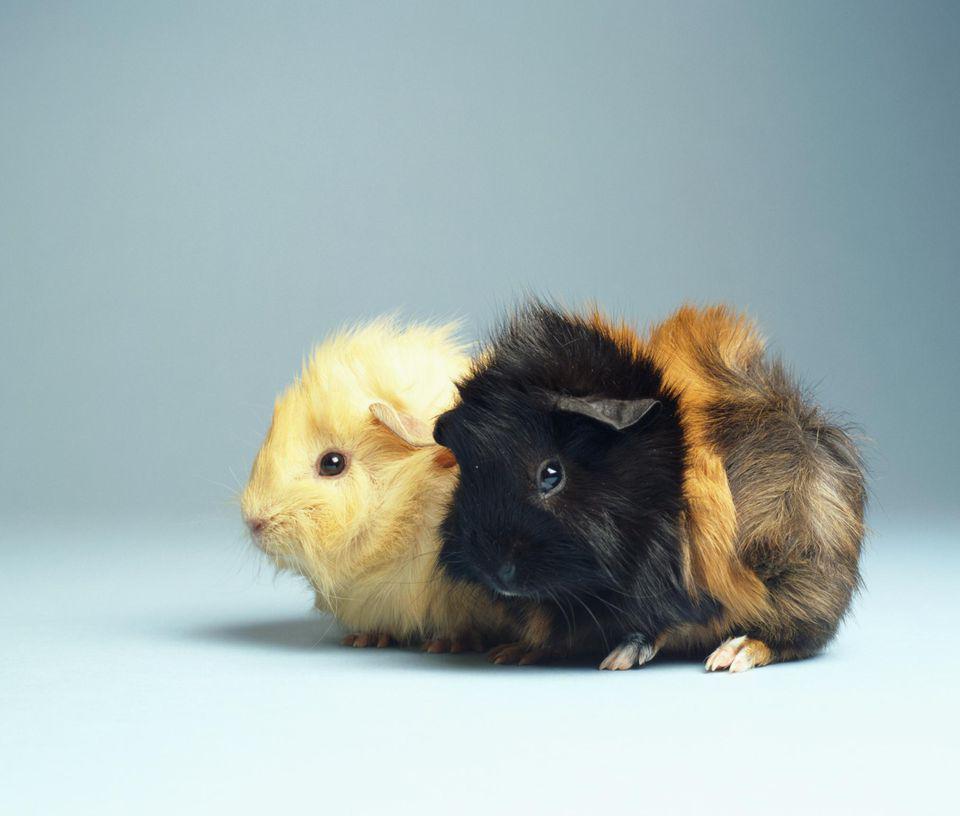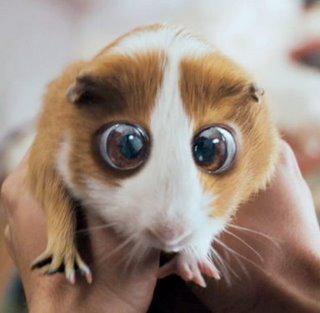The first image is the image on the left, the second image is the image on the right. For the images displayed, is the sentence "There are two guinea pigs in one image." factually correct? Answer yes or no. Yes. 